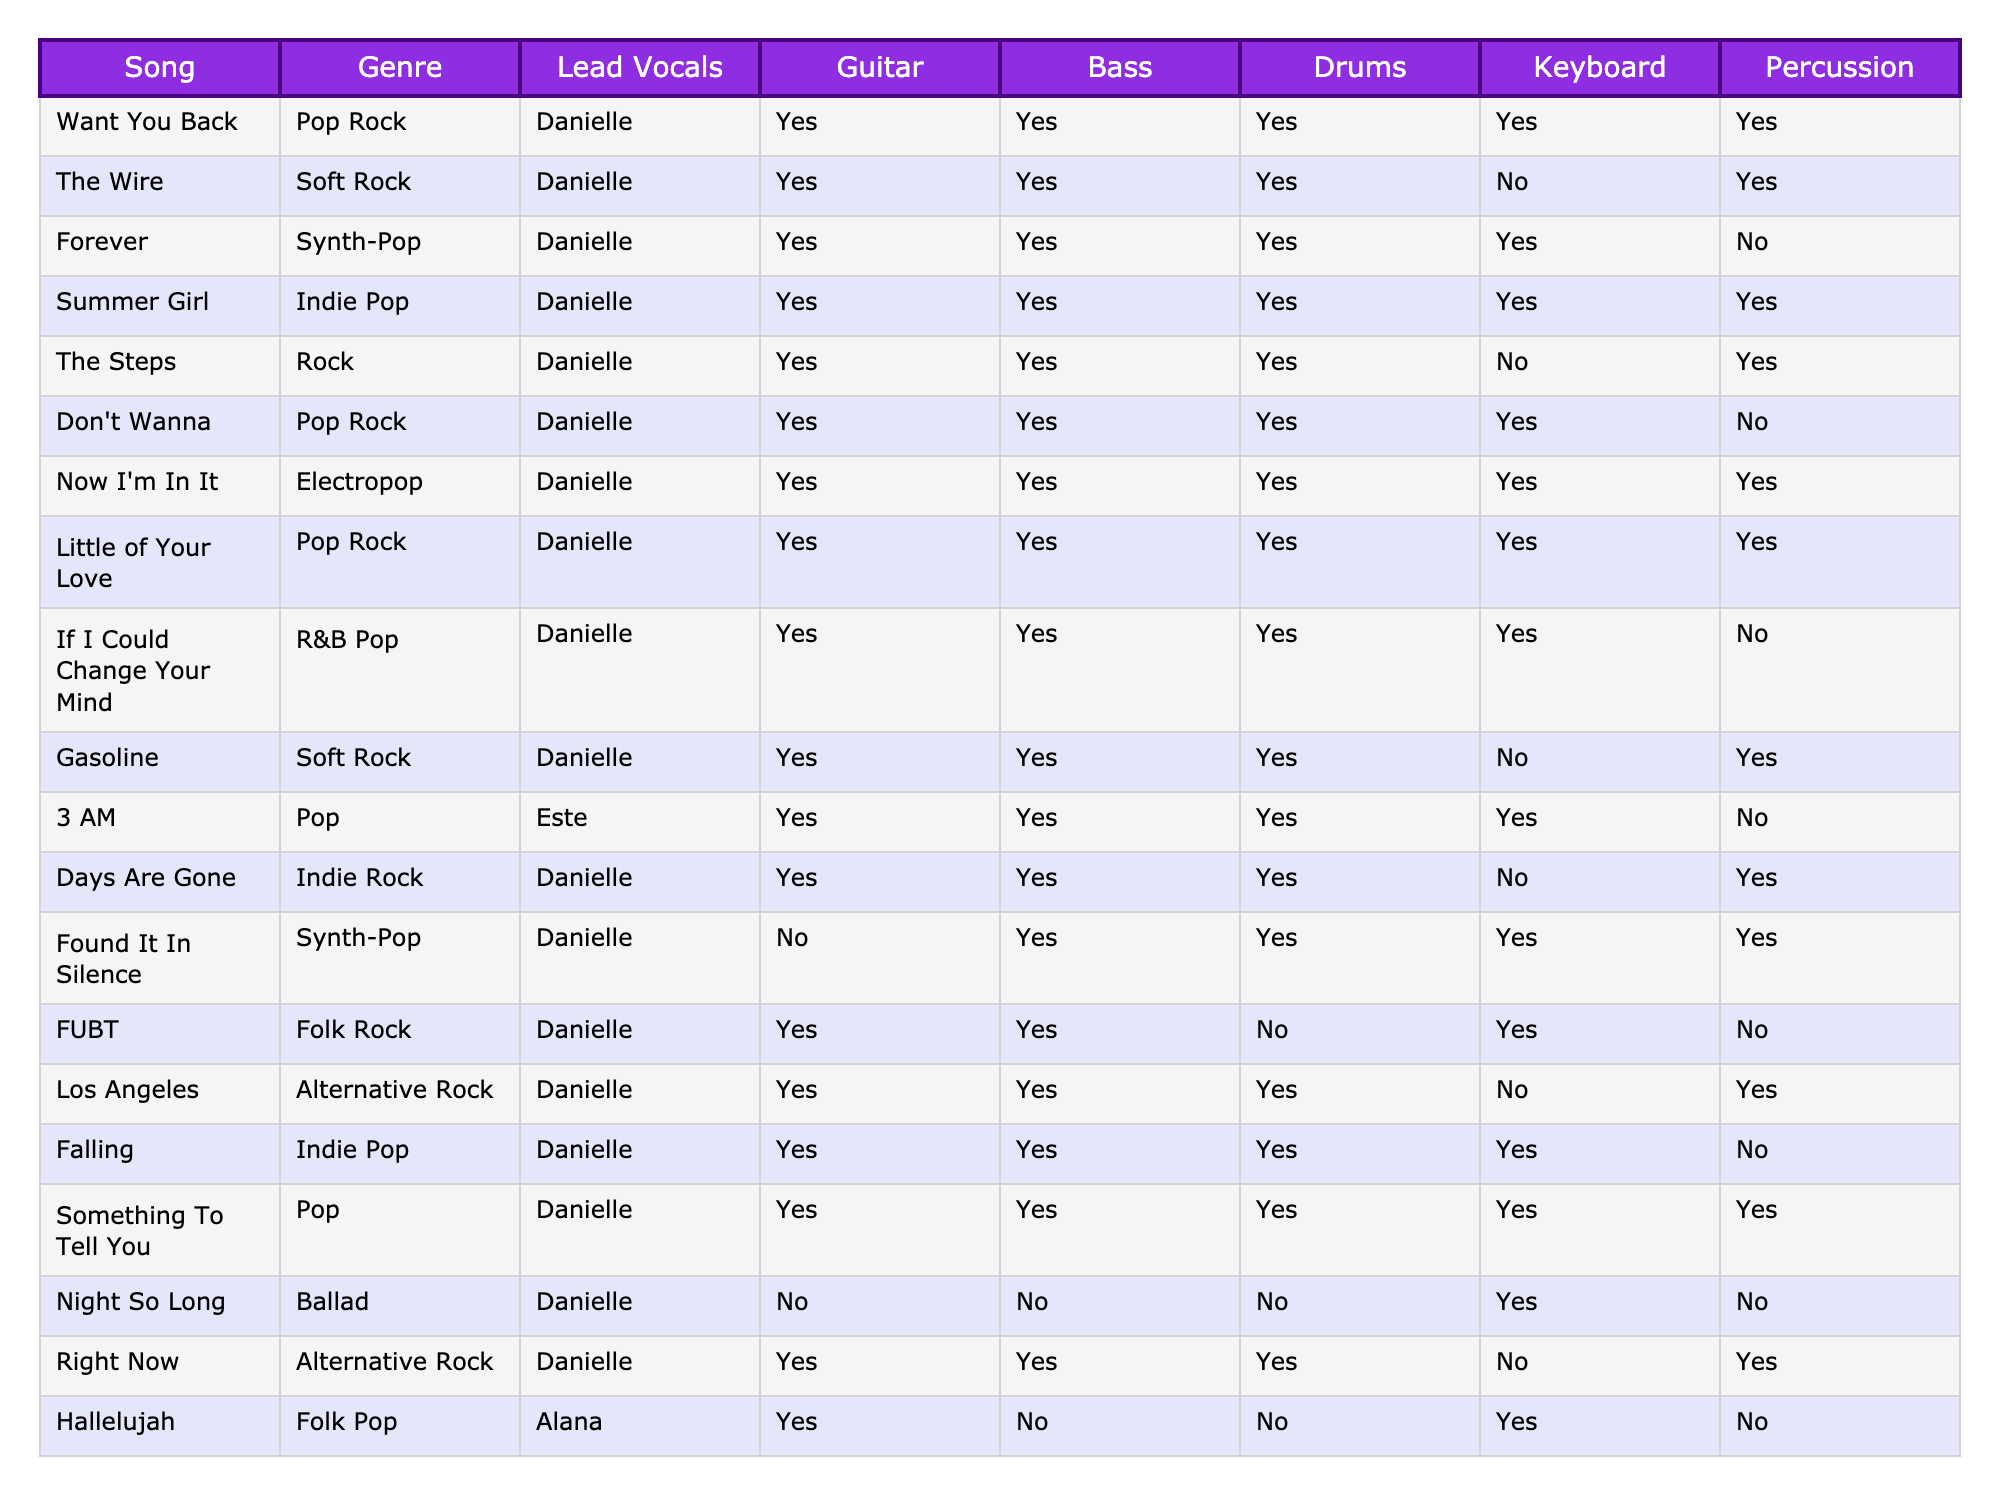What genre is "Now I'm In It"? The genre of "Now I'm In It" is listed under the Genre column, which shows it as Electropop.
Answer: Electropop How many songs in the table include keyboard usage? By counting the number of songs with "Yes" in the Keyboard column, there are 10 songs that include keyboard usage.
Answer: 10 Is "Falling" performed by Este? The table indicates that "Falling" is performed by Danielle, as mentioned in the Lead Vocals column.
Answer: No Which song has the genre "Folk Rock" and does it use drums? The song "FUBT" is listed under the Folk Rock genre, and the table indicates that it uses drums (Yes).
Answer: Yes What is the total number of songs listed in the table? Counting all the songs in the table leads to a total of 14 songs listed.
Answer: 14 How many songs feature Alana on lead vocals? There is one song featuring Alana on lead vocals, which is "Hallelujah" according to the Lead Vocals column.
Answer: 1 Which genre appears most frequently in the table? By examining the Genre column, “Pop Rock” appears 4 times, making it the most frequent genre.
Answer: Pop Rock Do any songs feature percussion but not drums? The table shows "Don't Wanna" and "The Steps" with percussion marked as Yes while drums are marked No, confirming that there are songs that feature percussion without drums.
Answer: Yes What percentage of songs use guitar? Since 12 out of 14 songs use guitar, the calculation is (12/14)*100 = 85.71%, thus approximately 86% of songs use guitar.
Answer: 86% Which song is the only one categorized under "Ballad"? The song "Night So Long" is the only song categorized under the Ballad genre, as seen in the Genre column.
Answer: Night So Long 